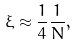<formula> <loc_0><loc_0><loc_500><loc_500>\xi \approx \frac { 1 } { 4 } \frac { 1 } { N } ,</formula> 